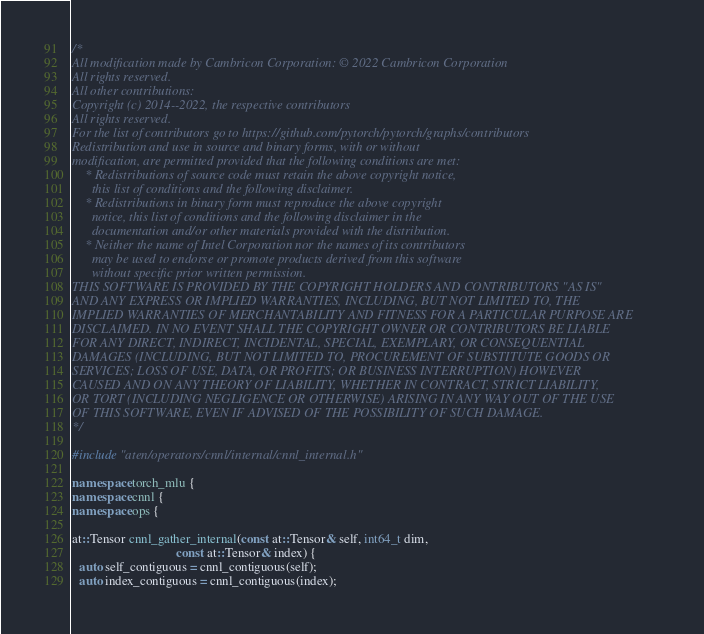<code> <loc_0><loc_0><loc_500><loc_500><_C++_>/*
All modification made by Cambricon Corporation: © 2022 Cambricon Corporation
All rights reserved.
All other contributions:
Copyright (c) 2014--2022, the respective contributors
All rights reserved.
For the list of contributors go to https://github.com/pytorch/pytorch/graphs/contributors
Redistribution and use in source and binary forms, with or without
modification, are permitted provided that the following conditions are met:
    * Redistributions of source code must retain the above copyright notice,
      this list of conditions and the following disclaimer.
    * Redistributions in binary form must reproduce the above copyright
      notice, this list of conditions and the following disclaimer in the
      documentation and/or other materials provided with the distribution.
    * Neither the name of Intel Corporation nor the names of its contributors
      may be used to endorse or promote products derived from this software
      without specific prior written permission.
THIS SOFTWARE IS PROVIDED BY THE COPYRIGHT HOLDERS AND CONTRIBUTORS "AS IS"
AND ANY EXPRESS OR IMPLIED WARRANTIES, INCLUDING, BUT NOT LIMITED TO, THE
IMPLIED WARRANTIES OF MERCHANTABILITY AND FITNESS FOR A PARTICULAR PURPOSE ARE
DISCLAIMED. IN NO EVENT SHALL THE COPYRIGHT OWNER OR CONTRIBUTORS BE LIABLE
FOR ANY DIRECT, INDIRECT, INCIDENTAL, SPECIAL, EXEMPLARY, OR CONSEQUENTIAL
DAMAGES (INCLUDING, BUT NOT LIMITED TO, PROCUREMENT OF SUBSTITUTE GOODS OR
SERVICES; LOSS OF USE, DATA, OR PROFITS; OR BUSINESS INTERRUPTION) HOWEVER
CAUSED AND ON ANY THEORY OF LIABILITY, WHETHER IN CONTRACT, STRICT LIABILITY,
OR TORT (INCLUDING NEGLIGENCE OR OTHERWISE) ARISING IN ANY WAY OUT OF THE USE
OF THIS SOFTWARE, EVEN IF ADVISED OF THE POSSIBILITY OF SUCH DAMAGE.
*/

#include "aten/operators/cnnl/internal/cnnl_internal.h"

namespace torch_mlu {
namespace cnnl {
namespace ops {

at::Tensor cnnl_gather_internal(const at::Tensor& self, int64_t dim,
                                const at::Tensor& index) {
  auto self_contiguous = cnnl_contiguous(self);
  auto index_contiguous = cnnl_contiguous(index);</code> 